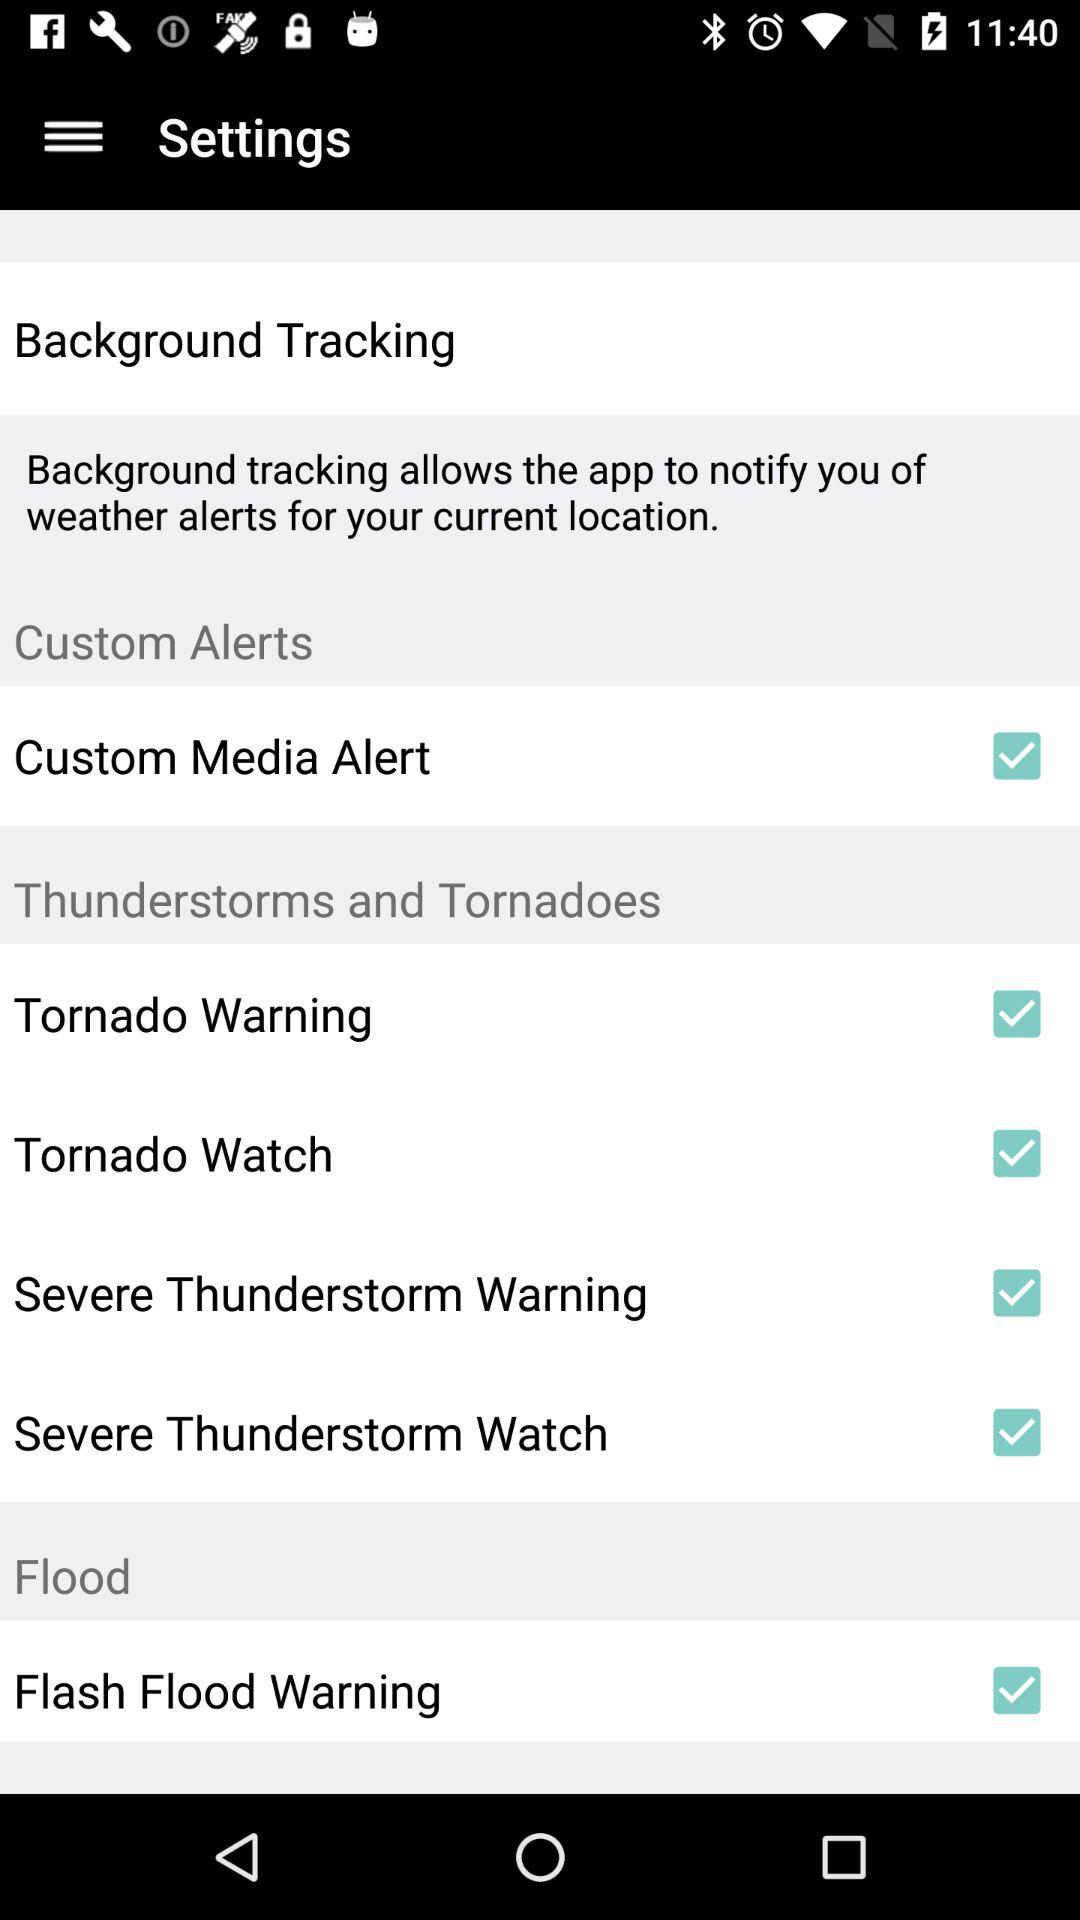How many alerts are there in total?
Answer the question using a single word or phrase. 6 